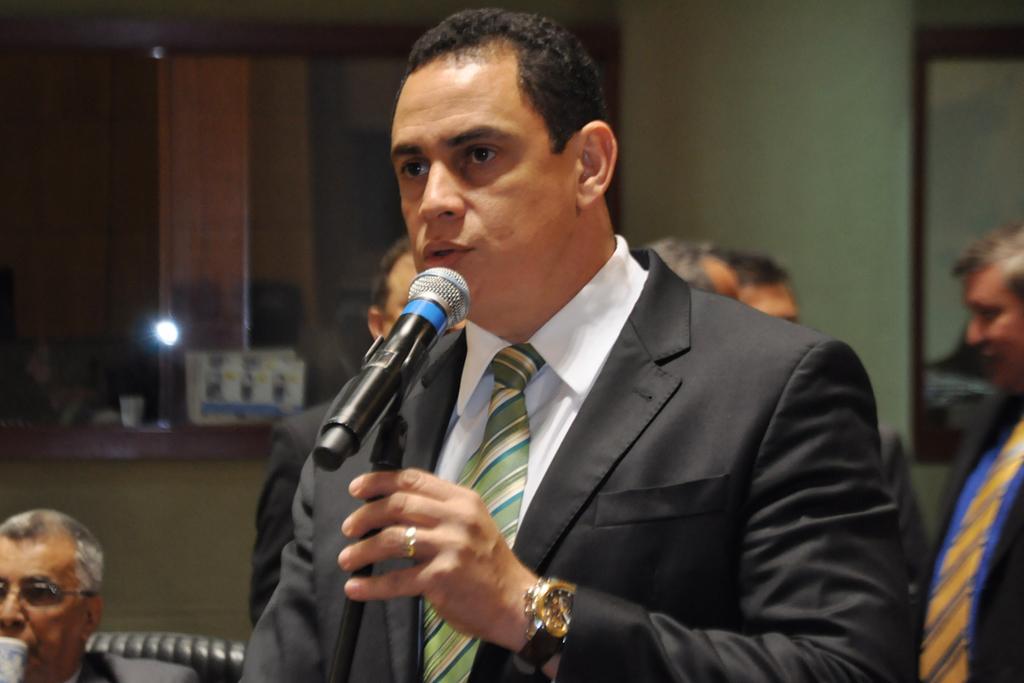Please provide a concise description of this image. In this image, we can see a man in a suit is talking in-front of a microphone and holding a rod. Background we can see few people, wall and some objects. 